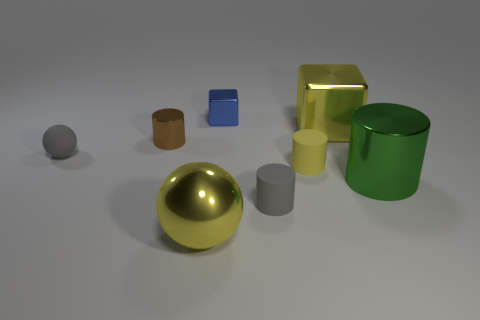What material is the large object on the left side of the small gray thing that is in front of the green metal object?
Provide a succinct answer. Metal. Is the shape of the large yellow metal thing that is behind the large ball the same as  the small blue thing?
Your answer should be compact. Yes. What is the color of the large cylinder that is made of the same material as the big ball?
Your answer should be compact. Green. What is the tiny gray object behind the tiny gray cylinder made of?
Provide a succinct answer. Rubber. There is a big green metal object; does it have the same shape as the small metal object to the left of the small blue shiny block?
Ensure brevity in your answer.  Yes. There is a big object that is both in front of the big cube and to the right of the tiny yellow matte object; what material is it made of?
Keep it short and to the point. Metal. The shiny sphere that is the same size as the yellow cube is what color?
Your answer should be very brief. Yellow. Does the brown thing have the same material as the large yellow object behind the large sphere?
Your answer should be compact. Yes. How many other things are the same size as the green cylinder?
Make the answer very short. 2. There is a small shiny object to the left of the yellow metallic object that is in front of the large green shiny thing; is there a big yellow metal block that is in front of it?
Ensure brevity in your answer.  No. 